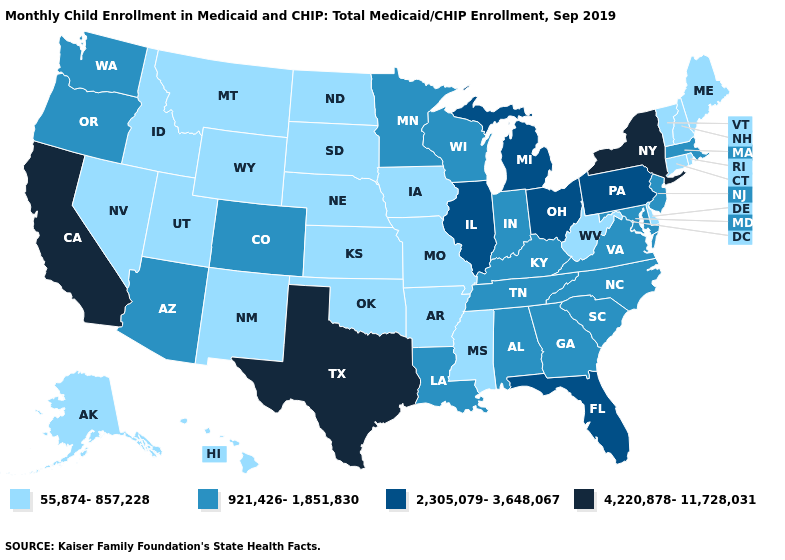Does Georgia have a lower value than Massachusetts?
Give a very brief answer. No. Name the states that have a value in the range 55,874-857,228?
Write a very short answer. Alaska, Arkansas, Connecticut, Delaware, Hawaii, Idaho, Iowa, Kansas, Maine, Mississippi, Missouri, Montana, Nebraska, Nevada, New Hampshire, New Mexico, North Dakota, Oklahoma, Rhode Island, South Dakota, Utah, Vermont, West Virginia, Wyoming. Among the states that border Georgia , which have the highest value?
Concise answer only. Florida. Which states have the lowest value in the USA?
Write a very short answer. Alaska, Arkansas, Connecticut, Delaware, Hawaii, Idaho, Iowa, Kansas, Maine, Mississippi, Missouri, Montana, Nebraska, Nevada, New Hampshire, New Mexico, North Dakota, Oklahoma, Rhode Island, South Dakota, Utah, Vermont, West Virginia, Wyoming. Does Wisconsin have the same value as California?
Give a very brief answer. No. How many symbols are there in the legend?
Concise answer only. 4. What is the value of Mississippi?
Quick response, please. 55,874-857,228. Does the first symbol in the legend represent the smallest category?
Concise answer only. Yes. What is the value of Hawaii?
Quick response, please. 55,874-857,228. What is the lowest value in the South?
Give a very brief answer. 55,874-857,228. What is the value of North Dakota?
Answer briefly. 55,874-857,228. Does the first symbol in the legend represent the smallest category?
Keep it brief. Yes. What is the value of Alaska?
Concise answer only. 55,874-857,228. Among the states that border Connecticut , which have the highest value?
Be succinct. New York. 